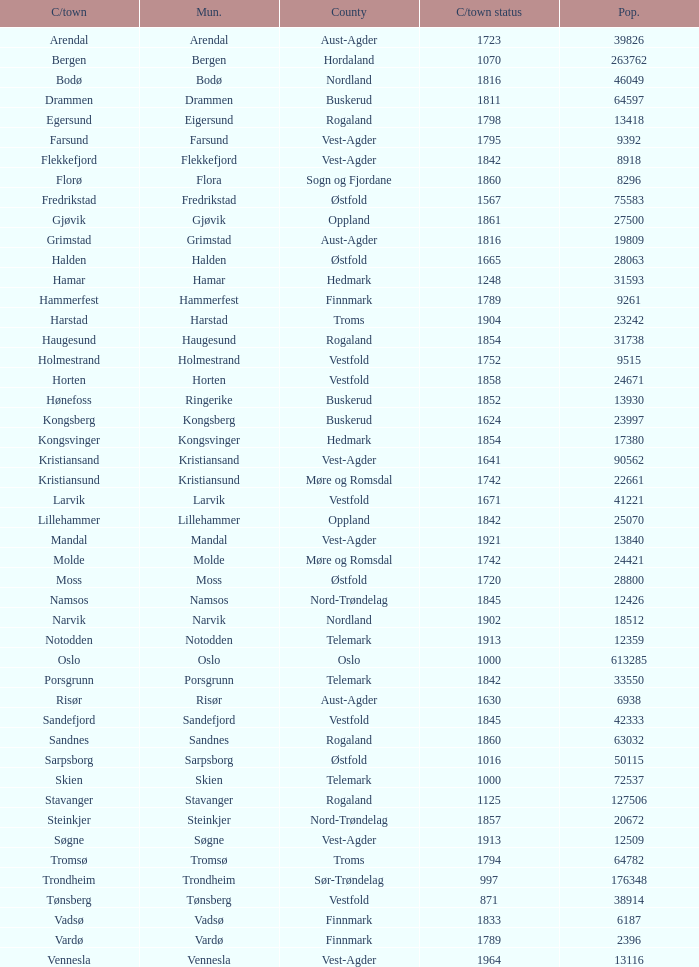What are the cities/towns located in the municipality of Moss? Moss. 